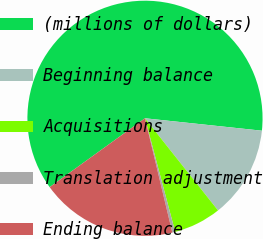Convert chart to OTSL. <chart><loc_0><loc_0><loc_500><loc_500><pie_chart><fcel>(millions of dollars)<fcel>Beginning balance<fcel>Acquisitions<fcel>Translation adjustment<fcel>Ending balance<nl><fcel>61.65%<fcel>12.65%<fcel>6.53%<fcel>0.4%<fcel>18.78%<nl></chart> 